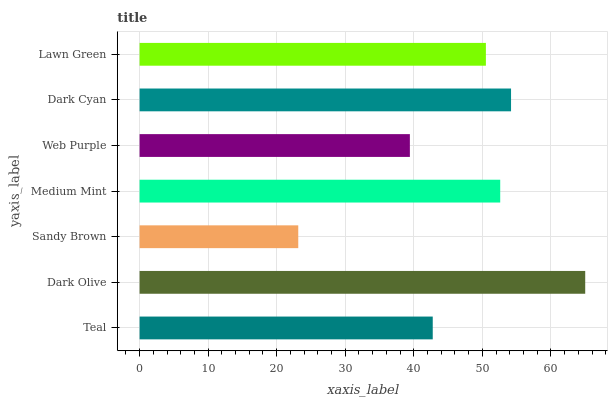Is Sandy Brown the minimum?
Answer yes or no. Yes. Is Dark Olive the maximum?
Answer yes or no. Yes. Is Dark Olive the minimum?
Answer yes or no. No. Is Sandy Brown the maximum?
Answer yes or no. No. Is Dark Olive greater than Sandy Brown?
Answer yes or no. Yes. Is Sandy Brown less than Dark Olive?
Answer yes or no. Yes. Is Sandy Brown greater than Dark Olive?
Answer yes or no. No. Is Dark Olive less than Sandy Brown?
Answer yes or no. No. Is Lawn Green the high median?
Answer yes or no. Yes. Is Lawn Green the low median?
Answer yes or no. Yes. Is Web Purple the high median?
Answer yes or no. No. Is Dark Cyan the low median?
Answer yes or no. No. 